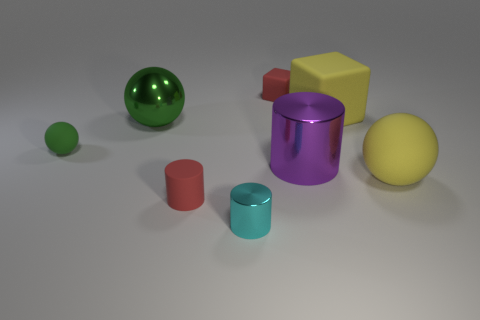Subtract all red balls. Subtract all gray cylinders. How many balls are left? 3 Add 1 large blue rubber cubes. How many objects exist? 9 Subtract all cylinders. How many objects are left? 5 Subtract all large green metallic objects. Subtract all large green cylinders. How many objects are left? 7 Add 7 big yellow cubes. How many big yellow cubes are left? 8 Add 8 yellow cubes. How many yellow cubes exist? 9 Subtract 1 purple cylinders. How many objects are left? 7 